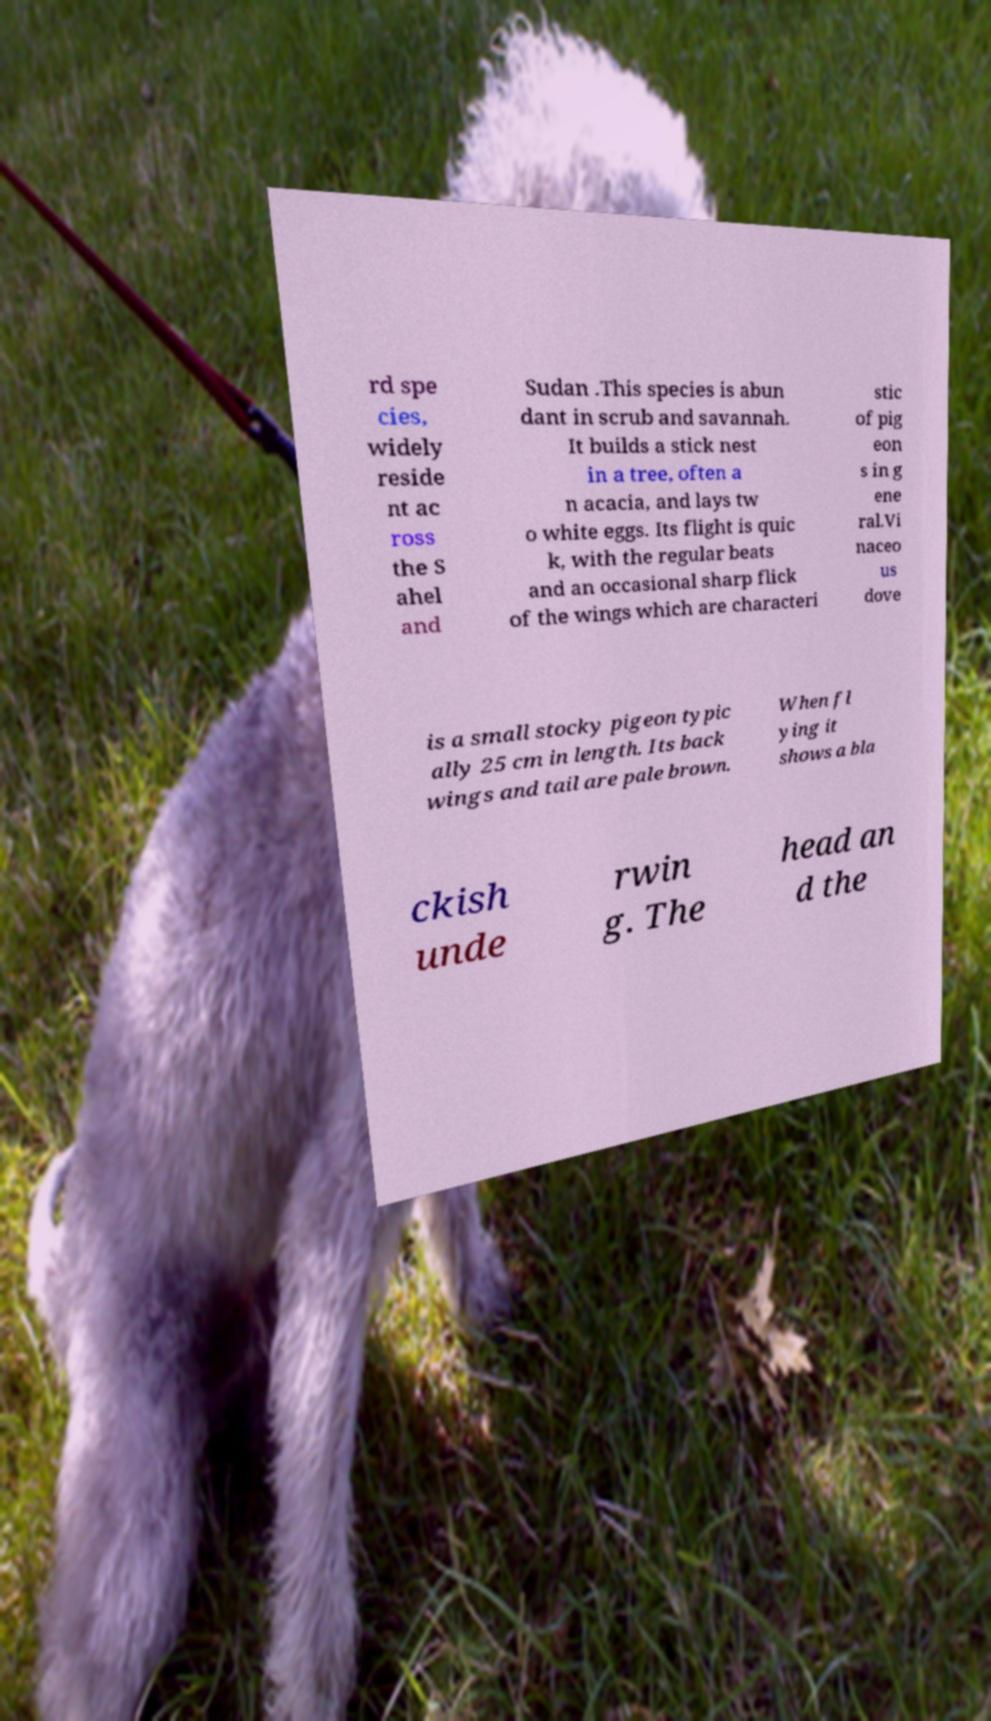Can you accurately transcribe the text from the provided image for me? rd spe cies, widely reside nt ac ross the S ahel and Sudan .This species is abun dant in scrub and savannah. It builds a stick nest in a tree, often a n acacia, and lays tw o white eggs. Its flight is quic k, with the regular beats and an occasional sharp flick of the wings which are characteri stic of pig eon s in g ene ral.Vi naceo us dove is a small stocky pigeon typic ally 25 cm in length. Its back wings and tail are pale brown. When fl ying it shows a bla ckish unde rwin g. The head an d the 